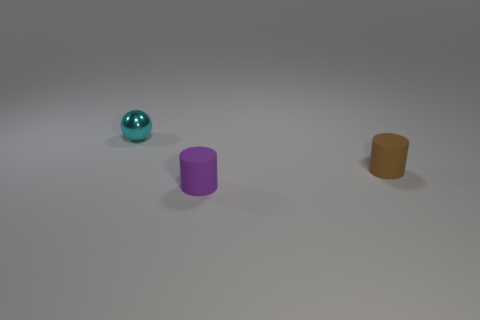Add 2 metallic objects. How many objects exist? 5 Subtract 1 cylinders. How many cylinders are left? 1 Subtract 1 brown cylinders. How many objects are left? 2 Subtract all balls. How many objects are left? 2 Subtract all blue balls. Subtract all purple blocks. How many balls are left? 1 Subtract all big green cylinders. Subtract all shiny spheres. How many objects are left? 2 Add 1 cyan shiny objects. How many cyan shiny objects are left? 2 Add 3 shiny spheres. How many shiny spheres exist? 4 